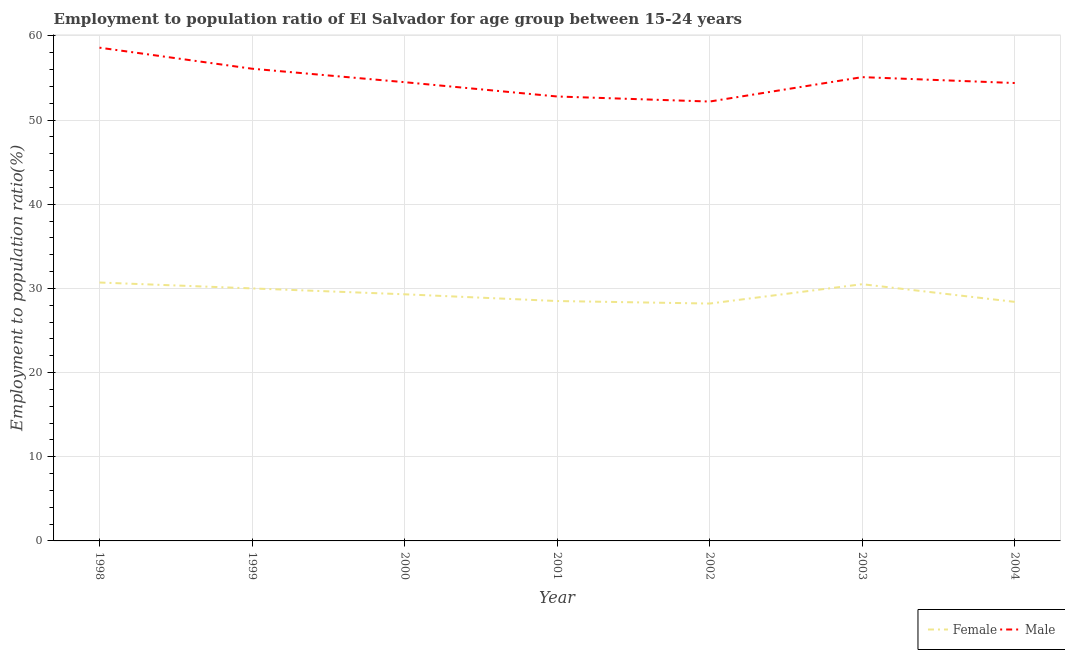Does the line corresponding to employment to population ratio(female) intersect with the line corresponding to employment to population ratio(male)?
Your answer should be very brief. No. Is the number of lines equal to the number of legend labels?
Your response must be concise. Yes. What is the employment to population ratio(female) in 2004?
Make the answer very short. 28.4. Across all years, what is the maximum employment to population ratio(male)?
Make the answer very short. 58.6. Across all years, what is the minimum employment to population ratio(male)?
Make the answer very short. 52.2. What is the total employment to population ratio(female) in the graph?
Your answer should be very brief. 205.6. What is the difference between the employment to population ratio(male) in 2001 and that in 2003?
Ensure brevity in your answer.  -2.3. What is the difference between the employment to population ratio(female) in 2001 and the employment to population ratio(male) in 1999?
Give a very brief answer. -27.6. What is the average employment to population ratio(female) per year?
Your answer should be compact. 29.37. In the year 2003, what is the difference between the employment to population ratio(female) and employment to population ratio(male)?
Provide a succinct answer. -24.6. What is the ratio of the employment to population ratio(male) in 2000 to that in 2003?
Your response must be concise. 0.99. What is the difference between the highest and the second highest employment to population ratio(female)?
Keep it short and to the point. 0.2. What is the difference between the highest and the lowest employment to population ratio(male)?
Provide a short and direct response. 6.4. In how many years, is the employment to population ratio(female) greater than the average employment to population ratio(female) taken over all years?
Keep it short and to the point. 3. Does the employment to population ratio(female) monotonically increase over the years?
Offer a very short reply. No. Is the employment to population ratio(female) strictly greater than the employment to population ratio(male) over the years?
Your answer should be compact. No. How many lines are there?
Offer a terse response. 2. How many years are there in the graph?
Your response must be concise. 7. Does the graph contain any zero values?
Provide a succinct answer. No. Does the graph contain grids?
Ensure brevity in your answer.  Yes. Where does the legend appear in the graph?
Keep it short and to the point. Bottom right. What is the title of the graph?
Your answer should be very brief. Employment to population ratio of El Salvador for age group between 15-24 years. Does "Merchandise imports" appear as one of the legend labels in the graph?
Your answer should be very brief. No. What is the label or title of the Y-axis?
Give a very brief answer. Employment to population ratio(%). What is the Employment to population ratio(%) in Female in 1998?
Provide a succinct answer. 30.7. What is the Employment to population ratio(%) of Male in 1998?
Make the answer very short. 58.6. What is the Employment to population ratio(%) of Female in 1999?
Keep it short and to the point. 30. What is the Employment to population ratio(%) of Male in 1999?
Your answer should be very brief. 56.1. What is the Employment to population ratio(%) in Female in 2000?
Your answer should be compact. 29.3. What is the Employment to population ratio(%) in Male in 2000?
Provide a succinct answer. 54.5. What is the Employment to population ratio(%) of Female in 2001?
Give a very brief answer. 28.5. What is the Employment to population ratio(%) of Male in 2001?
Make the answer very short. 52.8. What is the Employment to population ratio(%) in Female in 2002?
Your answer should be very brief. 28.2. What is the Employment to population ratio(%) of Male in 2002?
Ensure brevity in your answer.  52.2. What is the Employment to population ratio(%) of Female in 2003?
Make the answer very short. 30.5. What is the Employment to population ratio(%) of Male in 2003?
Provide a short and direct response. 55.1. What is the Employment to population ratio(%) of Female in 2004?
Make the answer very short. 28.4. What is the Employment to population ratio(%) in Male in 2004?
Offer a very short reply. 54.4. Across all years, what is the maximum Employment to population ratio(%) of Female?
Provide a succinct answer. 30.7. Across all years, what is the maximum Employment to population ratio(%) of Male?
Keep it short and to the point. 58.6. Across all years, what is the minimum Employment to population ratio(%) in Female?
Your answer should be compact. 28.2. Across all years, what is the minimum Employment to population ratio(%) in Male?
Your response must be concise. 52.2. What is the total Employment to population ratio(%) of Female in the graph?
Make the answer very short. 205.6. What is the total Employment to population ratio(%) of Male in the graph?
Provide a short and direct response. 383.7. What is the difference between the Employment to population ratio(%) of Female in 1998 and that in 1999?
Your answer should be compact. 0.7. What is the difference between the Employment to population ratio(%) in Male in 1998 and that in 1999?
Offer a very short reply. 2.5. What is the difference between the Employment to population ratio(%) in Female in 1998 and that in 2001?
Offer a very short reply. 2.2. What is the difference between the Employment to population ratio(%) in Female in 1998 and that in 2002?
Your answer should be compact. 2.5. What is the difference between the Employment to population ratio(%) of Female in 1998 and that in 2003?
Give a very brief answer. 0.2. What is the difference between the Employment to population ratio(%) of Female in 1998 and that in 2004?
Ensure brevity in your answer.  2.3. What is the difference between the Employment to population ratio(%) of Male in 1999 and that in 2002?
Keep it short and to the point. 3.9. What is the difference between the Employment to population ratio(%) of Male in 1999 and that in 2003?
Your answer should be very brief. 1. What is the difference between the Employment to population ratio(%) in Male in 1999 and that in 2004?
Offer a very short reply. 1.7. What is the difference between the Employment to population ratio(%) of Male in 2000 and that in 2001?
Your answer should be very brief. 1.7. What is the difference between the Employment to population ratio(%) of Female in 2000 and that in 2002?
Give a very brief answer. 1.1. What is the difference between the Employment to population ratio(%) of Male in 2000 and that in 2002?
Offer a very short reply. 2.3. What is the difference between the Employment to population ratio(%) of Female in 2000 and that in 2003?
Give a very brief answer. -1.2. What is the difference between the Employment to population ratio(%) in Male in 2000 and that in 2003?
Your answer should be very brief. -0.6. What is the difference between the Employment to population ratio(%) in Male in 2000 and that in 2004?
Your response must be concise. 0.1. What is the difference between the Employment to population ratio(%) of Female in 2001 and that in 2002?
Provide a short and direct response. 0.3. What is the difference between the Employment to population ratio(%) in Male in 2001 and that in 2002?
Offer a terse response. 0.6. What is the difference between the Employment to population ratio(%) of Male in 2001 and that in 2004?
Your answer should be compact. -1.6. What is the difference between the Employment to population ratio(%) of Male in 2002 and that in 2003?
Your answer should be very brief. -2.9. What is the difference between the Employment to population ratio(%) in Female in 2002 and that in 2004?
Provide a succinct answer. -0.2. What is the difference between the Employment to population ratio(%) of Male in 2002 and that in 2004?
Make the answer very short. -2.2. What is the difference between the Employment to population ratio(%) in Female in 1998 and the Employment to population ratio(%) in Male in 1999?
Provide a short and direct response. -25.4. What is the difference between the Employment to population ratio(%) of Female in 1998 and the Employment to population ratio(%) of Male in 2000?
Your answer should be very brief. -23.8. What is the difference between the Employment to population ratio(%) of Female in 1998 and the Employment to population ratio(%) of Male in 2001?
Offer a terse response. -22.1. What is the difference between the Employment to population ratio(%) of Female in 1998 and the Employment to population ratio(%) of Male in 2002?
Your answer should be very brief. -21.5. What is the difference between the Employment to population ratio(%) of Female in 1998 and the Employment to population ratio(%) of Male in 2003?
Ensure brevity in your answer.  -24.4. What is the difference between the Employment to population ratio(%) of Female in 1998 and the Employment to population ratio(%) of Male in 2004?
Your response must be concise. -23.7. What is the difference between the Employment to population ratio(%) in Female in 1999 and the Employment to population ratio(%) in Male in 2000?
Provide a short and direct response. -24.5. What is the difference between the Employment to population ratio(%) of Female in 1999 and the Employment to population ratio(%) of Male in 2001?
Keep it short and to the point. -22.8. What is the difference between the Employment to population ratio(%) of Female in 1999 and the Employment to population ratio(%) of Male in 2002?
Your answer should be very brief. -22.2. What is the difference between the Employment to population ratio(%) of Female in 1999 and the Employment to population ratio(%) of Male in 2003?
Offer a very short reply. -25.1. What is the difference between the Employment to population ratio(%) in Female in 1999 and the Employment to population ratio(%) in Male in 2004?
Keep it short and to the point. -24.4. What is the difference between the Employment to population ratio(%) of Female in 2000 and the Employment to population ratio(%) of Male in 2001?
Your answer should be compact. -23.5. What is the difference between the Employment to population ratio(%) of Female in 2000 and the Employment to population ratio(%) of Male in 2002?
Give a very brief answer. -22.9. What is the difference between the Employment to population ratio(%) in Female in 2000 and the Employment to population ratio(%) in Male in 2003?
Offer a very short reply. -25.8. What is the difference between the Employment to population ratio(%) in Female in 2000 and the Employment to population ratio(%) in Male in 2004?
Your response must be concise. -25.1. What is the difference between the Employment to population ratio(%) in Female in 2001 and the Employment to population ratio(%) in Male in 2002?
Ensure brevity in your answer.  -23.7. What is the difference between the Employment to population ratio(%) of Female in 2001 and the Employment to population ratio(%) of Male in 2003?
Your response must be concise. -26.6. What is the difference between the Employment to population ratio(%) in Female in 2001 and the Employment to population ratio(%) in Male in 2004?
Ensure brevity in your answer.  -25.9. What is the difference between the Employment to population ratio(%) of Female in 2002 and the Employment to population ratio(%) of Male in 2003?
Give a very brief answer. -26.9. What is the difference between the Employment to population ratio(%) of Female in 2002 and the Employment to population ratio(%) of Male in 2004?
Provide a short and direct response. -26.2. What is the difference between the Employment to population ratio(%) of Female in 2003 and the Employment to population ratio(%) of Male in 2004?
Keep it short and to the point. -23.9. What is the average Employment to population ratio(%) in Female per year?
Offer a very short reply. 29.37. What is the average Employment to population ratio(%) in Male per year?
Your answer should be compact. 54.81. In the year 1998, what is the difference between the Employment to population ratio(%) of Female and Employment to population ratio(%) of Male?
Offer a very short reply. -27.9. In the year 1999, what is the difference between the Employment to population ratio(%) in Female and Employment to population ratio(%) in Male?
Offer a very short reply. -26.1. In the year 2000, what is the difference between the Employment to population ratio(%) of Female and Employment to population ratio(%) of Male?
Your answer should be very brief. -25.2. In the year 2001, what is the difference between the Employment to population ratio(%) in Female and Employment to population ratio(%) in Male?
Keep it short and to the point. -24.3. In the year 2002, what is the difference between the Employment to population ratio(%) of Female and Employment to population ratio(%) of Male?
Provide a succinct answer. -24. In the year 2003, what is the difference between the Employment to population ratio(%) in Female and Employment to population ratio(%) in Male?
Keep it short and to the point. -24.6. In the year 2004, what is the difference between the Employment to population ratio(%) of Female and Employment to population ratio(%) of Male?
Provide a short and direct response. -26. What is the ratio of the Employment to population ratio(%) of Female in 1998 to that in 1999?
Offer a very short reply. 1.02. What is the ratio of the Employment to population ratio(%) in Male in 1998 to that in 1999?
Your response must be concise. 1.04. What is the ratio of the Employment to population ratio(%) of Female in 1998 to that in 2000?
Offer a very short reply. 1.05. What is the ratio of the Employment to population ratio(%) in Male in 1998 to that in 2000?
Offer a terse response. 1.08. What is the ratio of the Employment to population ratio(%) of Female in 1998 to that in 2001?
Your answer should be very brief. 1.08. What is the ratio of the Employment to population ratio(%) of Male in 1998 to that in 2001?
Make the answer very short. 1.11. What is the ratio of the Employment to population ratio(%) in Female in 1998 to that in 2002?
Offer a very short reply. 1.09. What is the ratio of the Employment to population ratio(%) in Male in 1998 to that in 2002?
Provide a short and direct response. 1.12. What is the ratio of the Employment to population ratio(%) in Female in 1998 to that in 2003?
Make the answer very short. 1.01. What is the ratio of the Employment to population ratio(%) in Male in 1998 to that in 2003?
Offer a very short reply. 1.06. What is the ratio of the Employment to population ratio(%) in Female in 1998 to that in 2004?
Offer a very short reply. 1.08. What is the ratio of the Employment to population ratio(%) in Male in 1998 to that in 2004?
Offer a terse response. 1.08. What is the ratio of the Employment to population ratio(%) of Female in 1999 to that in 2000?
Your answer should be very brief. 1.02. What is the ratio of the Employment to population ratio(%) of Male in 1999 to that in 2000?
Give a very brief answer. 1.03. What is the ratio of the Employment to population ratio(%) of Female in 1999 to that in 2001?
Provide a succinct answer. 1.05. What is the ratio of the Employment to population ratio(%) of Male in 1999 to that in 2001?
Ensure brevity in your answer.  1.06. What is the ratio of the Employment to population ratio(%) in Female in 1999 to that in 2002?
Your answer should be compact. 1.06. What is the ratio of the Employment to population ratio(%) of Male in 1999 to that in 2002?
Give a very brief answer. 1.07. What is the ratio of the Employment to population ratio(%) in Female in 1999 to that in 2003?
Your answer should be compact. 0.98. What is the ratio of the Employment to population ratio(%) in Male in 1999 to that in 2003?
Ensure brevity in your answer.  1.02. What is the ratio of the Employment to population ratio(%) of Female in 1999 to that in 2004?
Your response must be concise. 1.06. What is the ratio of the Employment to population ratio(%) of Male in 1999 to that in 2004?
Your response must be concise. 1.03. What is the ratio of the Employment to population ratio(%) of Female in 2000 to that in 2001?
Offer a very short reply. 1.03. What is the ratio of the Employment to population ratio(%) in Male in 2000 to that in 2001?
Make the answer very short. 1.03. What is the ratio of the Employment to population ratio(%) of Female in 2000 to that in 2002?
Ensure brevity in your answer.  1.04. What is the ratio of the Employment to population ratio(%) of Male in 2000 to that in 2002?
Your answer should be very brief. 1.04. What is the ratio of the Employment to population ratio(%) in Female in 2000 to that in 2003?
Your answer should be compact. 0.96. What is the ratio of the Employment to population ratio(%) in Male in 2000 to that in 2003?
Your response must be concise. 0.99. What is the ratio of the Employment to population ratio(%) in Female in 2000 to that in 2004?
Provide a succinct answer. 1.03. What is the ratio of the Employment to population ratio(%) in Male in 2000 to that in 2004?
Your answer should be very brief. 1. What is the ratio of the Employment to population ratio(%) of Female in 2001 to that in 2002?
Make the answer very short. 1.01. What is the ratio of the Employment to population ratio(%) in Male in 2001 to that in 2002?
Your answer should be compact. 1.01. What is the ratio of the Employment to population ratio(%) of Female in 2001 to that in 2003?
Make the answer very short. 0.93. What is the ratio of the Employment to population ratio(%) in Male in 2001 to that in 2003?
Your answer should be compact. 0.96. What is the ratio of the Employment to population ratio(%) in Female in 2001 to that in 2004?
Ensure brevity in your answer.  1. What is the ratio of the Employment to population ratio(%) in Male in 2001 to that in 2004?
Give a very brief answer. 0.97. What is the ratio of the Employment to population ratio(%) of Female in 2002 to that in 2003?
Your answer should be very brief. 0.92. What is the ratio of the Employment to population ratio(%) of Male in 2002 to that in 2004?
Provide a short and direct response. 0.96. What is the ratio of the Employment to population ratio(%) in Female in 2003 to that in 2004?
Your response must be concise. 1.07. What is the ratio of the Employment to population ratio(%) of Male in 2003 to that in 2004?
Provide a succinct answer. 1.01. What is the difference between the highest and the lowest Employment to population ratio(%) in Female?
Your answer should be very brief. 2.5. 